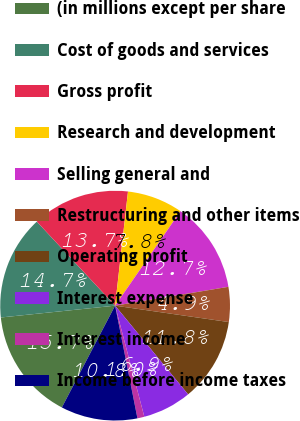Convert chart. <chart><loc_0><loc_0><loc_500><loc_500><pie_chart><fcel>(in millions except per share<fcel>Cost of goods and services<fcel>Gross profit<fcel>Research and development<fcel>Selling general and<fcel>Restructuring and other items<fcel>Operating profit<fcel>Interest expense<fcel>Interest income<fcel>Income before income taxes<nl><fcel>15.68%<fcel>14.7%<fcel>13.72%<fcel>7.84%<fcel>12.74%<fcel>4.9%<fcel>11.76%<fcel>6.86%<fcel>0.98%<fcel>10.78%<nl></chart> 